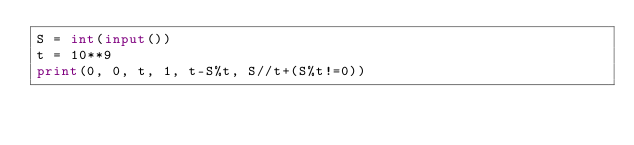Convert code to text. <code><loc_0><loc_0><loc_500><loc_500><_Python_>S = int(input())
t = 10**9
print(0, 0, t, 1, t-S%t, S//t+(S%t!=0))
</code> 